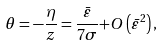<formula> <loc_0><loc_0><loc_500><loc_500>\theta = - \frac { \eta } { z } = \frac { { \bar { \varepsilon } } } { 7 \sigma } { + O } \left ( \bar { \varepsilon } ^ { 2 } \right ) ,</formula> 